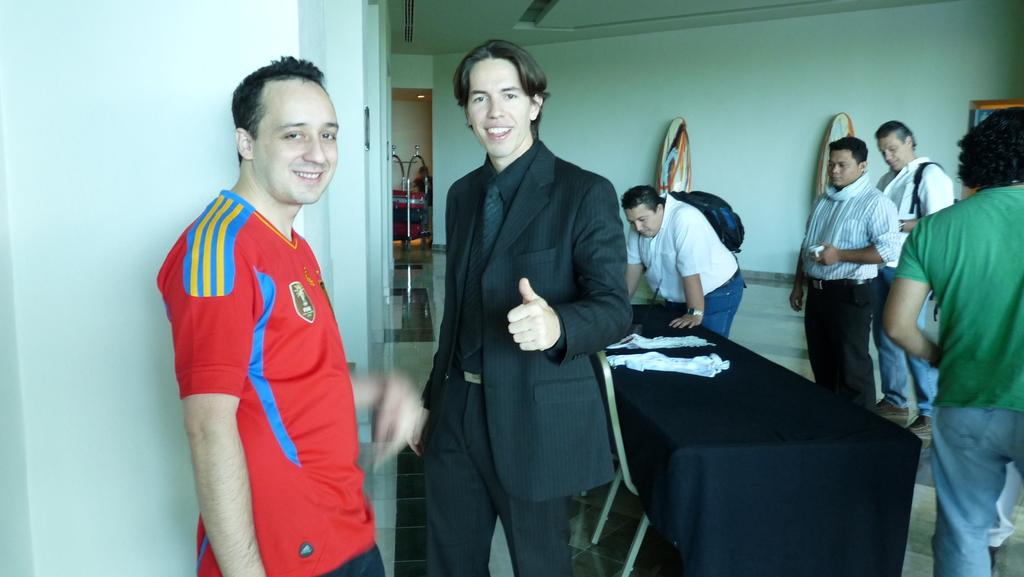What can be seen in the background of the image? There is a wall and surfboards in the background of the image. What is present in the foreground of the image? There is a table in the image, and people are standing in front of it. Can you describe the people in the image? Two men are standing and smiling in the image. What type of cap is the sun wearing in the image? There is no sun or cap present in the image. Can you tell me when the birth of the surfboards took place in the image? There is no birth or specific time associated with the surfboards in the image; they are simply visible in the background. 